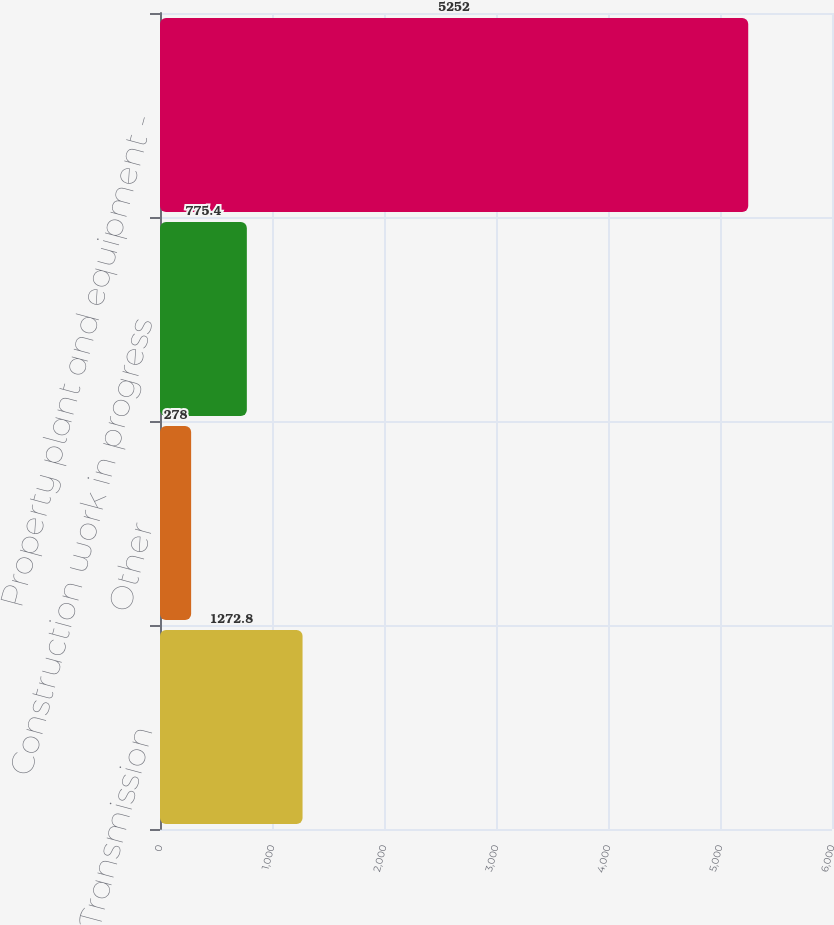Convert chart to OTSL. <chart><loc_0><loc_0><loc_500><loc_500><bar_chart><fcel>Transmission<fcel>Other<fcel>Construction work in progress<fcel>Property plant and equipment -<nl><fcel>1272.8<fcel>278<fcel>775.4<fcel>5252<nl></chart> 